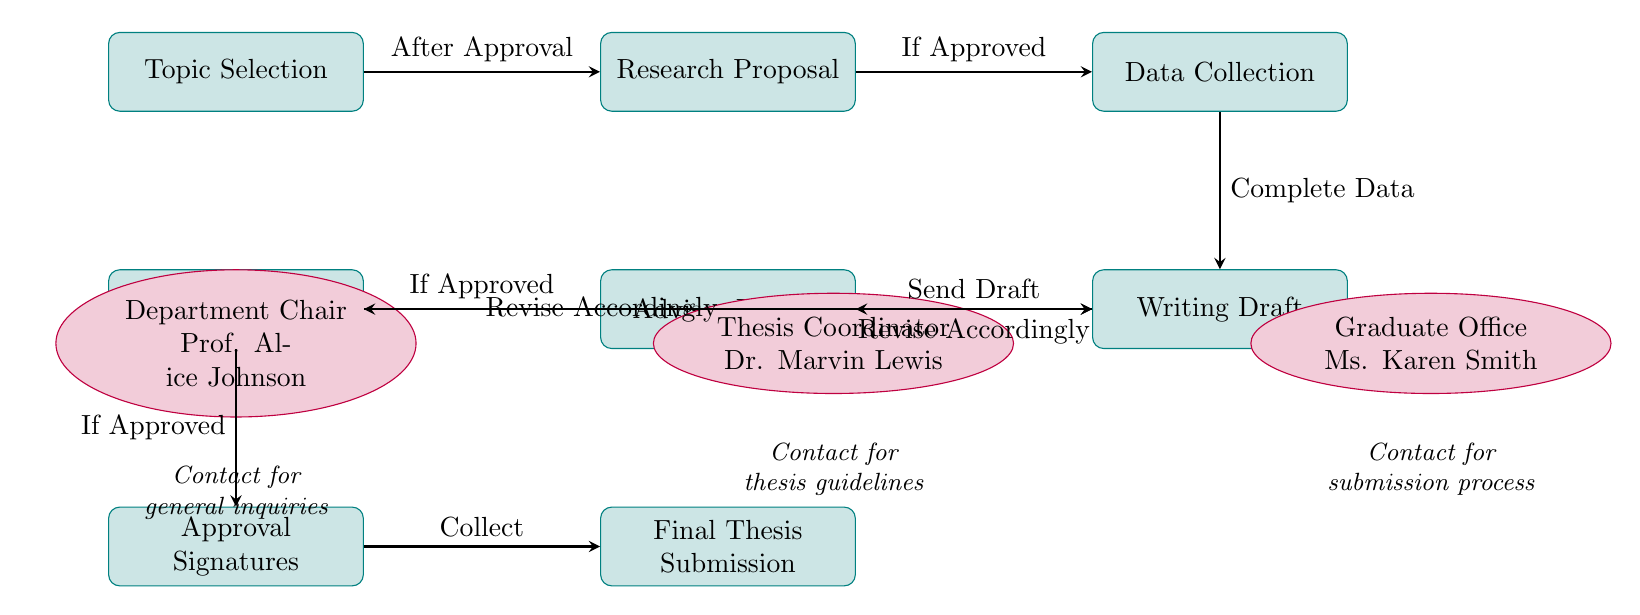What's the first step in the thesis submission process? The first step, as shown in the diagram, is "Topic Selection," which initiates the process before moving on to subsequent stages.
Answer: Topic Selection How many main stages are there in the thesis submission process? Counting the main stages listed in the diagram, we find six distinct stages: Topic Selection, Research Proposal, Data Collection, Writing Draft, Committee Review, and Final Thesis Submission.
Answer: Six What do you need to do after the Advisor Review step? After the Advisor Review, if the draft is approved, the next step is to proceed to the Committee Review, as indicated by the flow of arrows in the diagram.
Answer: Committee Review Who is the contact for thesis guidelines? The diagram specifies that the contact for thesis guidelines is the Thesis Coordinator, Dr. Marvin Lewis.
Answer: Thesis Coordinator If the student needs to revise the draft after the Committee Review, what should they do next? After revising the draft according to the Committee's feedback, the student should return to the Writing Draft stage as per the diagram's flow.
Answer: Writing Draft What happens if the Research Proposal is not approved? The diagram indicates that if the Research Proposal is not approved, the process cannot move forward to Data Collection; the next action would not proceed to that step.
Answer: Not Proceed Which step follows the Approval Signatures? After collecting the Approval Signatures, the next step, as shown, is the Final Thesis Submission.
Answer: Final Thesis Submission What is the role of the Department Chair in the thesis submission process? The Department Chair, Prof. Alice Johnson, is mentioned as a contact for general inquiries related to the thesis submission process, likely serving as a supervisory or administrative role.
Answer: General inquiries How do you obtain the Approval Signatures? To obtain Approval Signatures, you must first complete both the Advisor Review and Committee Review, as approved by both parties in the process flow.
Answer: After Advisor and Committee approval 